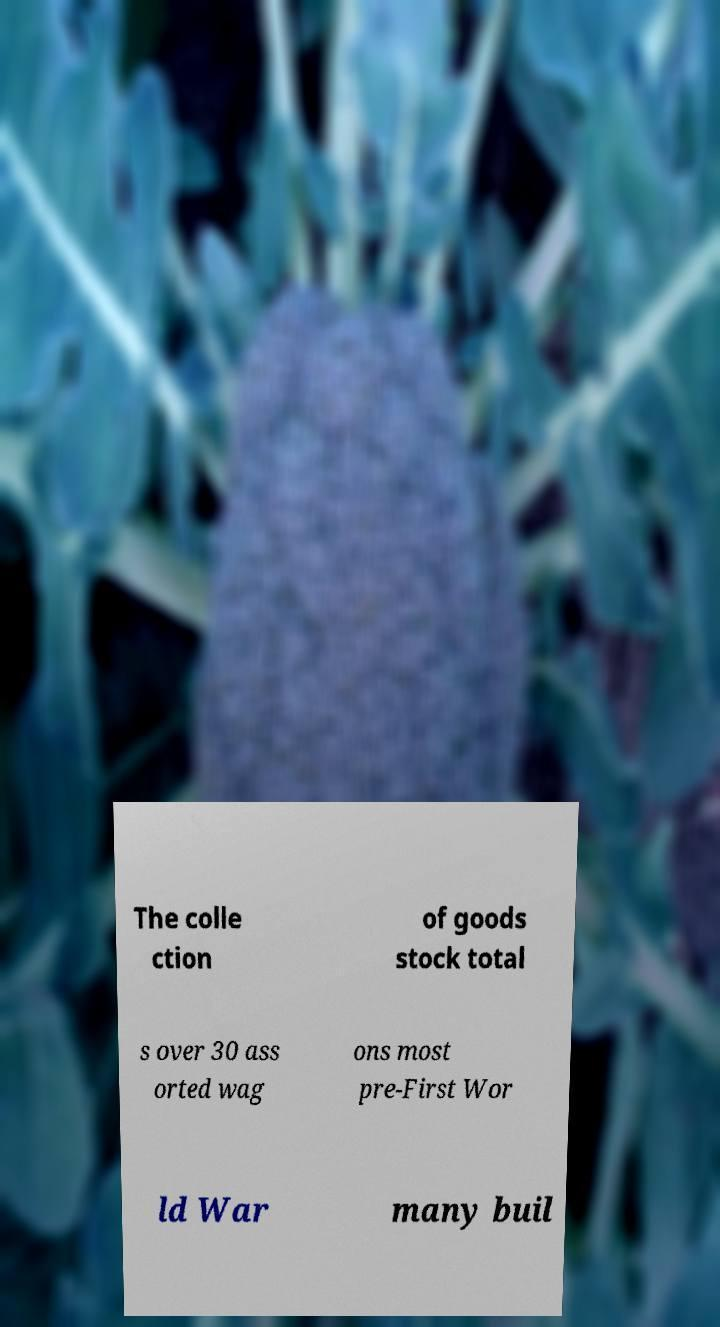Can you read and provide the text displayed in the image?This photo seems to have some interesting text. Can you extract and type it out for me? The colle ction of goods stock total s over 30 ass orted wag ons most pre-First Wor ld War many buil 